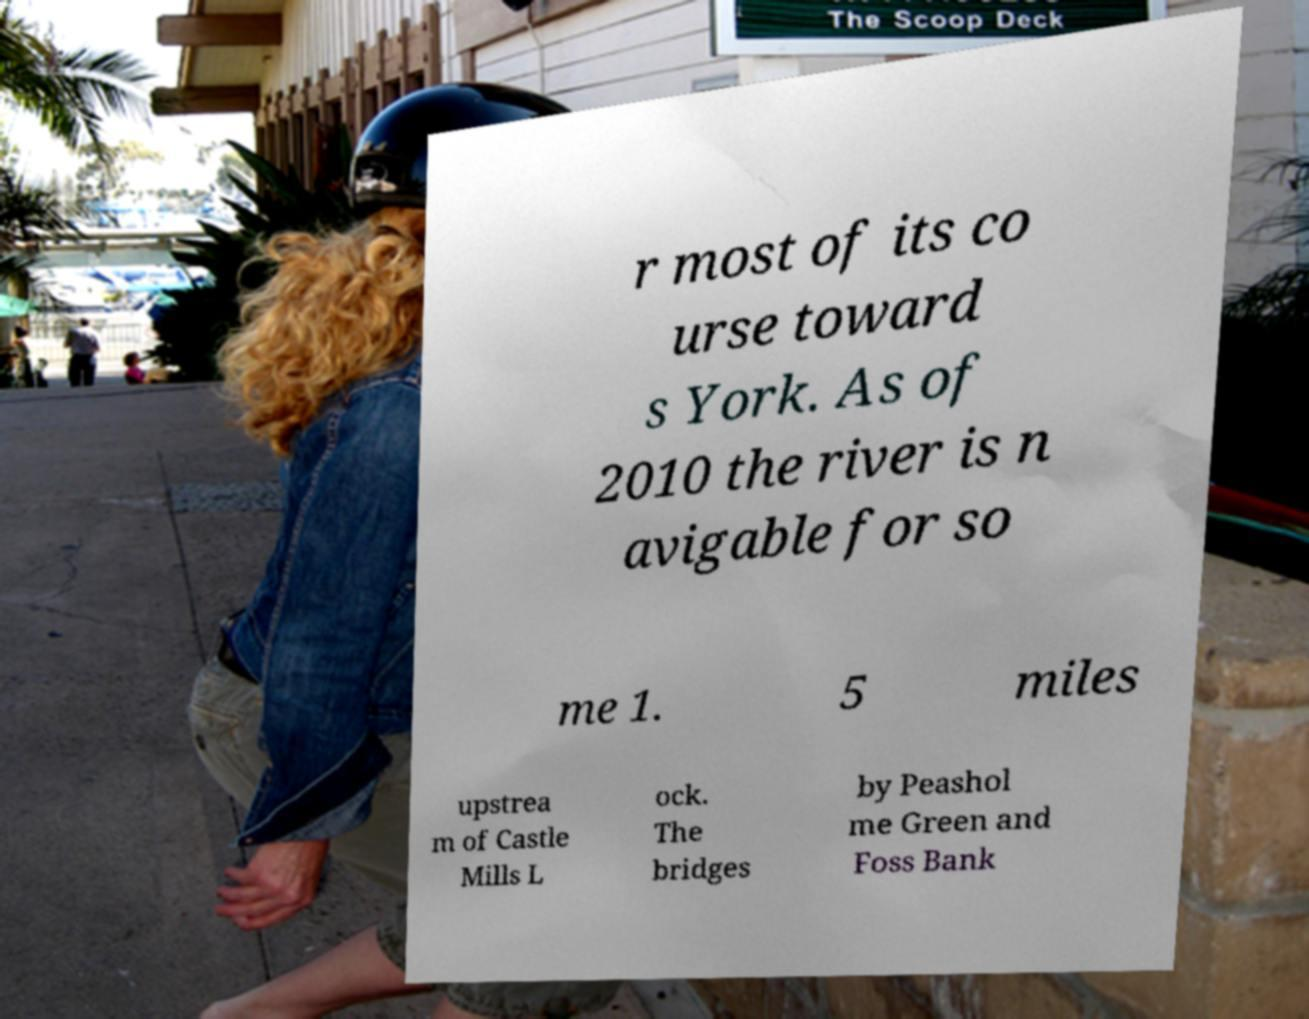There's text embedded in this image that I need extracted. Can you transcribe it verbatim? r most of its co urse toward s York. As of 2010 the river is n avigable for so me 1. 5 miles upstrea m of Castle Mills L ock. The bridges by Peashol me Green and Foss Bank 